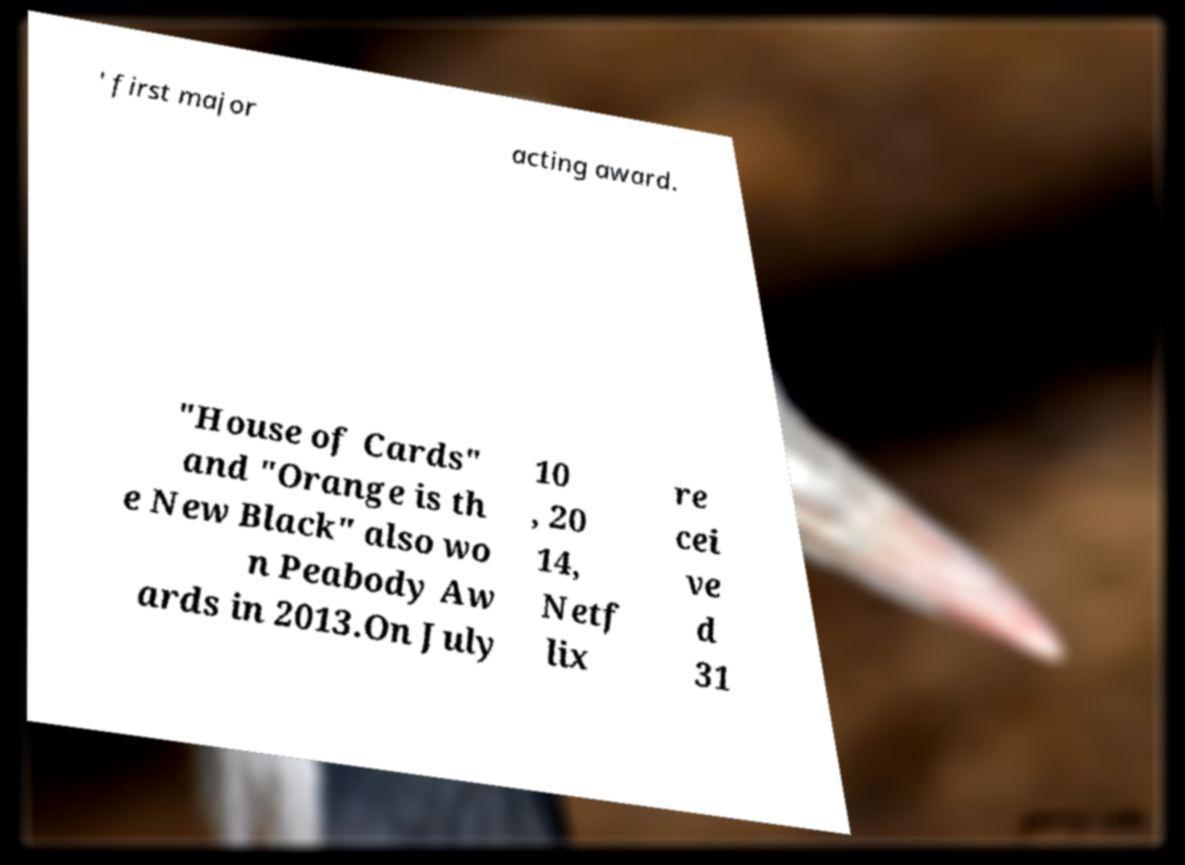I need the written content from this picture converted into text. Can you do that? ' first major acting award. "House of Cards" and "Orange is th e New Black" also wo n Peabody Aw ards in 2013.On July 10 , 20 14, Netf lix re cei ve d 31 